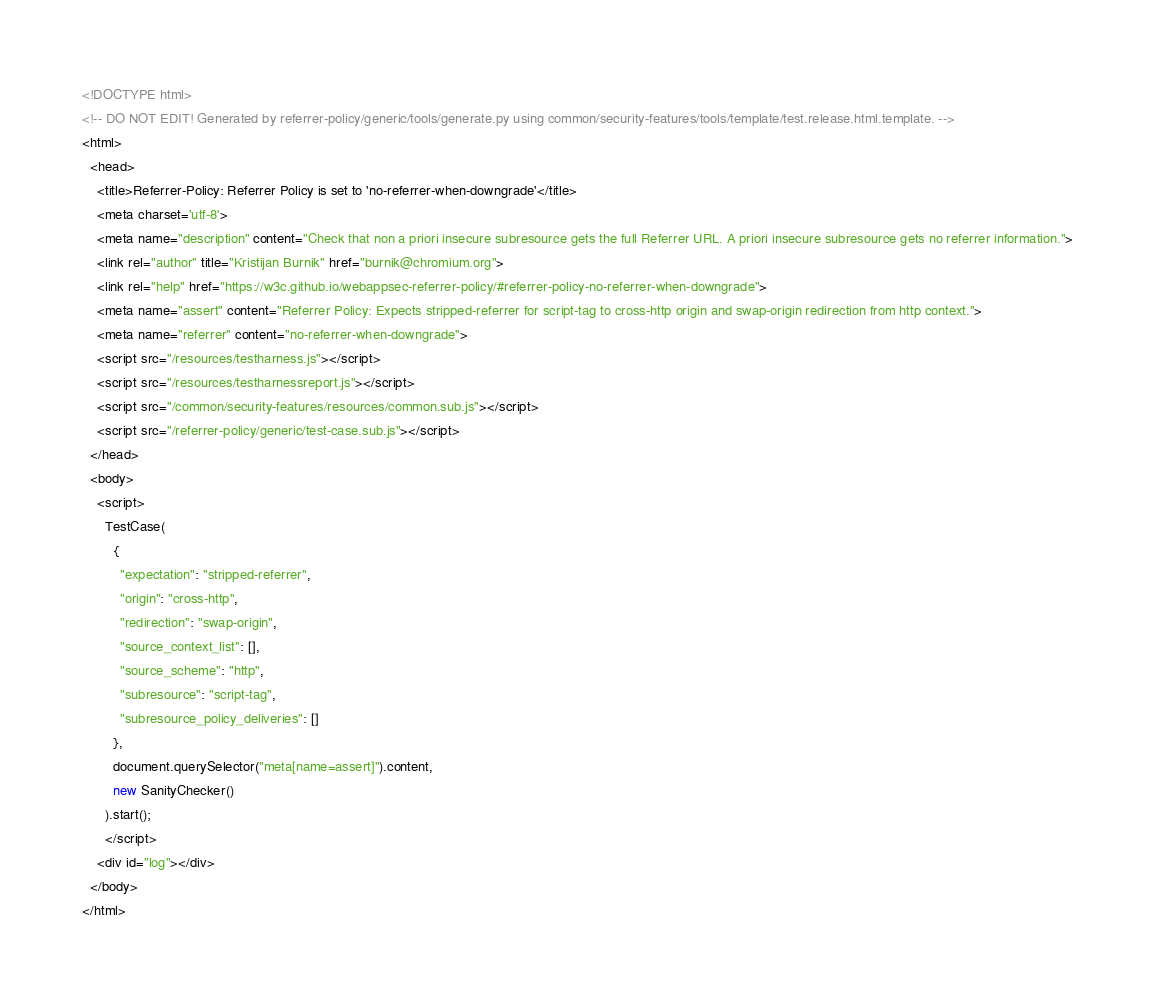<code> <loc_0><loc_0><loc_500><loc_500><_HTML_><!DOCTYPE html>
<!-- DO NOT EDIT! Generated by referrer-policy/generic/tools/generate.py using common/security-features/tools/template/test.release.html.template. -->
<html>
  <head>
    <title>Referrer-Policy: Referrer Policy is set to 'no-referrer-when-downgrade'</title>
    <meta charset='utf-8'>
    <meta name="description" content="Check that non a priori insecure subresource gets the full Referrer URL. A priori insecure subresource gets no referrer information.">
    <link rel="author" title="Kristijan Burnik" href="burnik@chromium.org">
    <link rel="help" href="https://w3c.github.io/webappsec-referrer-policy/#referrer-policy-no-referrer-when-downgrade">
    <meta name="assert" content="Referrer Policy: Expects stripped-referrer for script-tag to cross-http origin and swap-origin redirection from http context.">
    <meta name="referrer" content="no-referrer-when-downgrade">
    <script src="/resources/testharness.js"></script>
    <script src="/resources/testharnessreport.js"></script>
    <script src="/common/security-features/resources/common.sub.js"></script>
    <script src="/referrer-policy/generic/test-case.sub.js"></script>
  </head>
  <body>
    <script>
      TestCase(
        {
          "expectation": "stripped-referrer",
          "origin": "cross-http",
          "redirection": "swap-origin",
          "source_context_list": [],
          "source_scheme": "http",
          "subresource": "script-tag",
          "subresource_policy_deliveries": []
        },
        document.querySelector("meta[name=assert]").content,
        new SanityChecker()
      ).start();
      </script>
    <div id="log"></div>
  </body>
</html>
</code> 